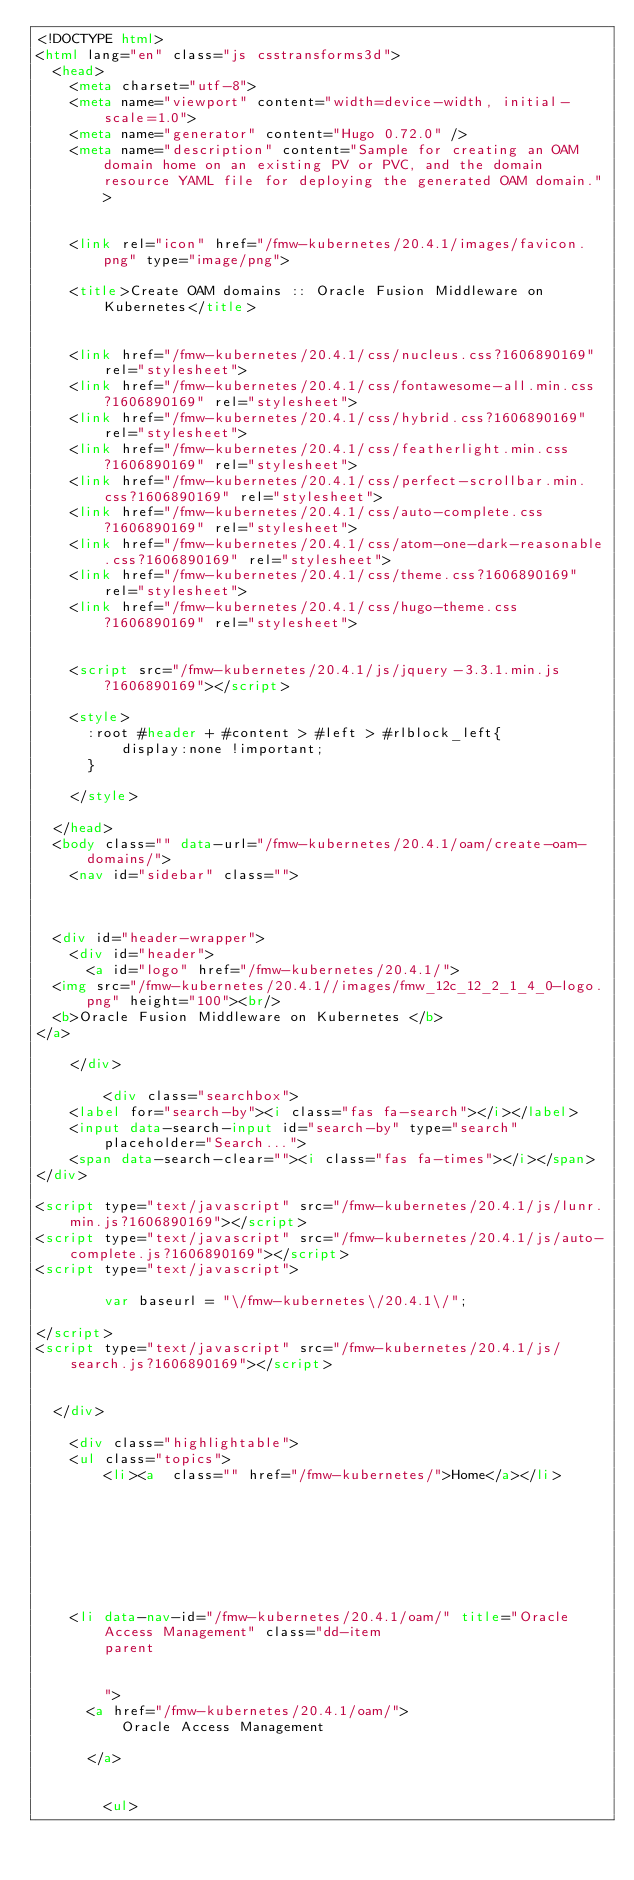<code> <loc_0><loc_0><loc_500><loc_500><_HTML_><!DOCTYPE html>
<html lang="en" class="js csstransforms3d">
  <head>
    <meta charset="utf-8">
    <meta name="viewport" content="width=device-width, initial-scale=1.0">
    <meta name="generator" content="Hugo 0.72.0" />
    <meta name="description" content="Sample for creating an OAM domain home on an existing PV or PVC, and the domain resource YAML file for deploying the generated OAM domain.">


    <link rel="icon" href="/fmw-kubernetes/20.4.1/images/favicon.png" type="image/png">

    <title>Create OAM domains :: Oracle Fusion Middleware on Kubernetes</title>

    
    <link href="/fmw-kubernetes/20.4.1/css/nucleus.css?1606890169" rel="stylesheet">
    <link href="/fmw-kubernetes/20.4.1/css/fontawesome-all.min.css?1606890169" rel="stylesheet">
    <link href="/fmw-kubernetes/20.4.1/css/hybrid.css?1606890169" rel="stylesheet">
    <link href="/fmw-kubernetes/20.4.1/css/featherlight.min.css?1606890169" rel="stylesheet">
    <link href="/fmw-kubernetes/20.4.1/css/perfect-scrollbar.min.css?1606890169" rel="stylesheet">
    <link href="/fmw-kubernetes/20.4.1/css/auto-complete.css?1606890169" rel="stylesheet">
    <link href="/fmw-kubernetes/20.4.1/css/atom-one-dark-reasonable.css?1606890169" rel="stylesheet">
    <link href="/fmw-kubernetes/20.4.1/css/theme.css?1606890169" rel="stylesheet">
    <link href="/fmw-kubernetes/20.4.1/css/hugo-theme.css?1606890169" rel="stylesheet">
    

    <script src="/fmw-kubernetes/20.4.1/js/jquery-3.3.1.min.js?1606890169"></script>

    <style>
      :root #header + #content > #left > #rlblock_left{
          display:none !important;
      }
      
    </style>
    
  </head>
  <body class="" data-url="/fmw-kubernetes/20.4.1/oam/create-oam-domains/">
    <nav id="sidebar" class="">



  <div id="header-wrapper">
    <div id="header">
      <a id="logo" href="/fmw-kubernetes/20.4.1/">
  <img src="/fmw-kubernetes/20.4.1//images/fmw_12c_12_2_1_4_0-logo.png" height="100"><br/>
  <b>Oracle Fusion Middleware on Kubernetes </b>
</a>

    </div>
    
        <div class="searchbox">
    <label for="search-by"><i class="fas fa-search"></i></label>
    <input data-search-input id="search-by" type="search" placeholder="Search...">
    <span data-search-clear=""><i class="fas fa-times"></i></span>
</div>

<script type="text/javascript" src="/fmw-kubernetes/20.4.1/js/lunr.min.js?1606890169"></script>
<script type="text/javascript" src="/fmw-kubernetes/20.4.1/js/auto-complete.js?1606890169"></script>
<script type="text/javascript">
    
        var baseurl = "\/fmw-kubernetes\/20.4.1\/";
    
</script>
<script type="text/javascript" src="/fmw-kubernetes/20.4.1/js/search.js?1606890169"></script>

    
  </div>

    <div class="highlightable">
    <ul class="topics">
        <li><a  class="" href="/fmw-kubernetes/">Home</a></li>
        
          
          


 
  
    
    <li data-nav-id="/fmw-kubernetes/20.4.1/oam/" title="Oracle Access Management" class="dd-item 
        parent
        
        
        ">
      <a href="/fmw-kubernetes/20.4.1/oam/">
          Oracle Access Management
          
      </a>
      
      
        <ul>
          
          
            
          
          
          
        
          
            
            


 
  
    </code> 